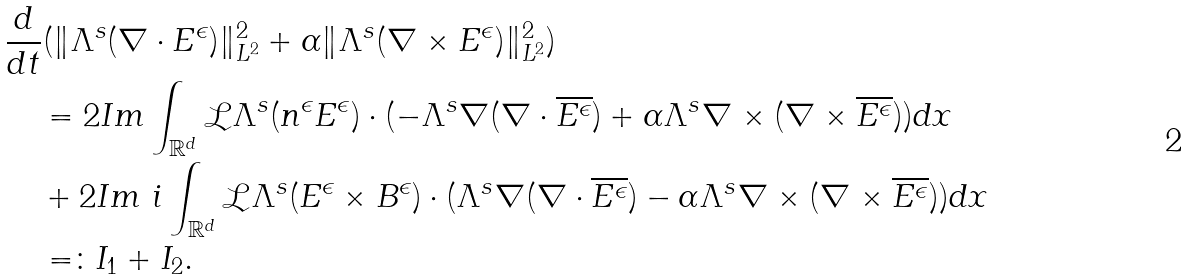<formula> <loc_0><loc_0><loc_500><loc_500>& \frac { d } { d t } ( \| \Lambda ^ { s } ( \nabla \cdot E ^ { \epsilon } ) \| _ { L ^ { 2 } } ^ { 2 } + \alpha \| \Lambda ^ { s } ( \nabla \times E ^ { \epsilon } ) \| _ { L ^ { 2 } } ^ { 2 } ) \\ & \quad = 2 I m \int _ { \mathbb { R } ^ { d } } \mathcal { L } \Lambda ^ { s } ( n ^ { \epsilon } E ^ { \epsilon } ) \cdot ( - \Lambda ^ { s } \nabla ( \nabla \cdot \overline { E ^ { \epsilon } } ) + \alpha \Lambda ^ { s } \nabla \times ( \nabla \times \overline { E ^ { \epsilon } } ) ) d x \\ & \quad + 2 I m \ i \int _ { \mathbb { R } ^ { d } } \mathcal { L } \Lambda ^ { s } ( E ^ { \epsilon } \times B ^ { \epsilon } ) \cdot ( \Lambda ^ { s } \nabla ( \nabla \cdot \overline { E ^ { \epsilon } } ) - \alpha \Lambda ^ { s } \nabla \times ( \nabla \times \overline { E ^ { \epsilon } } ) ) d x \\ & \quad = \colon I _ { 1 } + I _ { 2 } .</formula> 